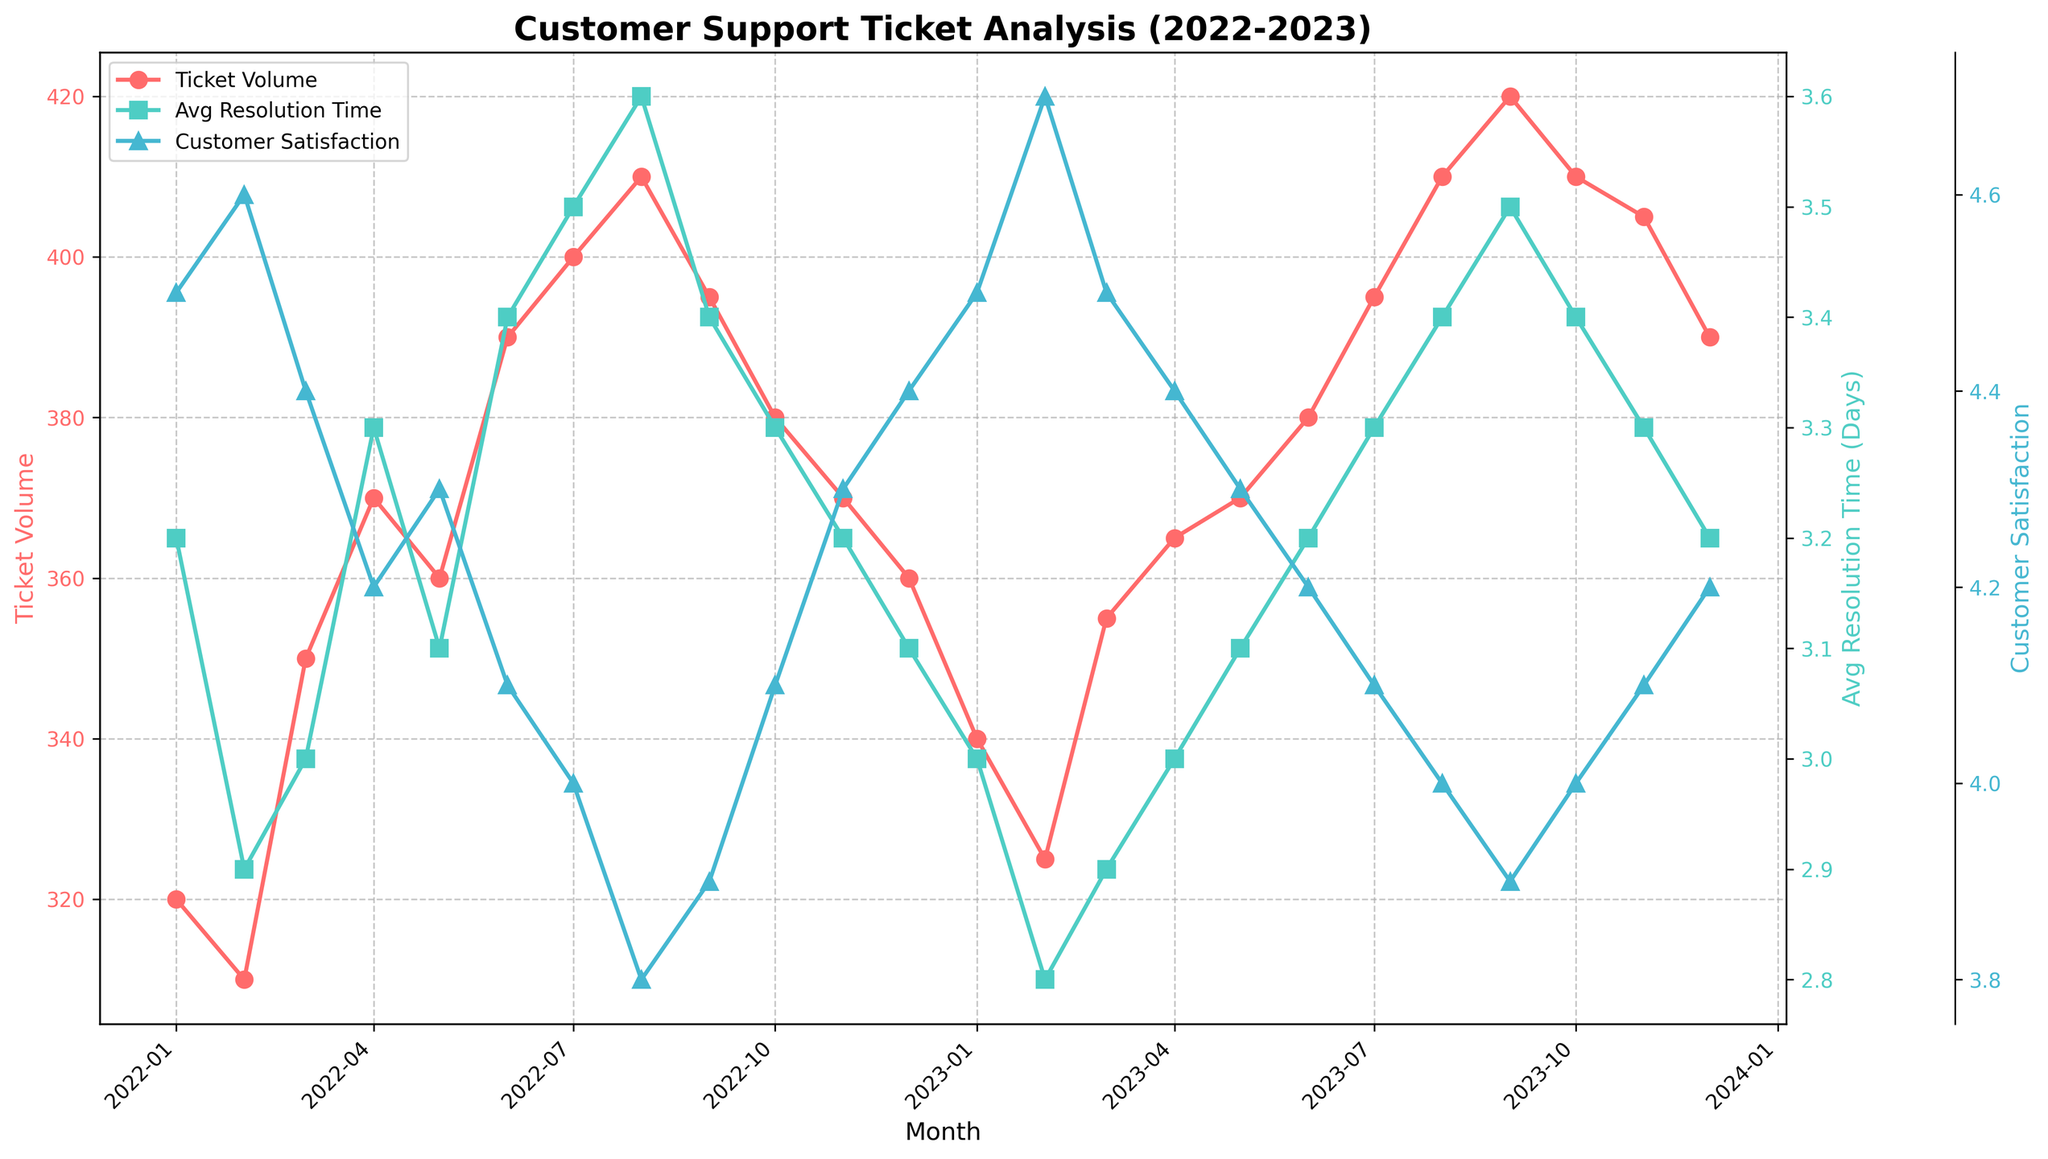What is the title of the figure? The title of the figure is the text that appears at the top and describes what the plot is about.
Answer: Customer Support Ticket Analysis (2022-2023) How many months of data are displayed in the plot? To determine the number of months, count the x-axis tick marks or the entries in the data. From January 2022 to December 2023, there are 24 months displayed.
Answer: 24 What was the average resolution time in February 2023? Locate February 2023 on the x-axis and read the corresponding value on the second y-axis for Resolution Time. The Resolution Time for February 2023 is 2.8 days.
Answer: 2.8 days How does the customer satisfaction in August 2023 compare to August 2022? Locate both August 2022 and August 2023 on the x-axis and compare the corresponding values on the third y-axis for Customer Satisfaction. Customer satisfaction was 3.8 in August 2022 and 4.0 in August 2023, so it increased.
Answer: Increased What are the colors used to represent Ticket Volume, Resolution Time, and Customer Satisfaction? Look at the line colors used in the plot and the legend. Ticket Volume is represented by red, Resolution Time by green, and Customer Satisfaction by blue.
Answer: Red, Green, Blue What is the trend of ticket volume from January 2022 to December 2023? Follow the line representing Ticket Volume from January 2022 to December 2023. The ticket volume generally increases, peaking around July-August each year, then slightly decreases at the end of the year.
Answer: Increasing trend Did the average resolution time and customer satisfaction move in the same direction during any months in 2023? Compare the trends of the Resolution Time and Customer Satisfaction lines month by month in 2023. Both Resolution Time and Customer Satisfaction moved down together in August and September 2023.
Answer: Yes, in August and September Which month had the highest number of tickets in the given period? Look for the peak point in the Ticket Volume line plot. September 2023 has the highest number of tickets at 420.
Answer: September 2023 What is the relationship between ticket volume and customer satisfaction in July 2022? Locate July 2022 on the x-axis and compare the values for both Ticket Volume and Customer Satisfaction. July 2022 had a high ticket volume of 400 and a lower satisfaction rating of 4.0.
Answer: High ticket volume, low satisfaction During which months in 2023 did the average resolution time drop below 3 days? Identify months in 2023 where the Resolution Time line falls below the 3-day mark. This occurred in February 2023 (2.8 days) and March 2023 (2.9 days).
Answer: February and March 